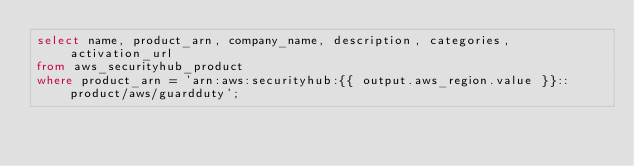<code> <loc_0><loc_0><loc_500><loc_500><_SQL_>select name, product_arn, company_name, description, categories, activation_url
from aws_securityhub_product
where product_arn = 'arn:aws:securityhub:{{ output.aws_region.value }}::product/aws/guardduty';
</code> 